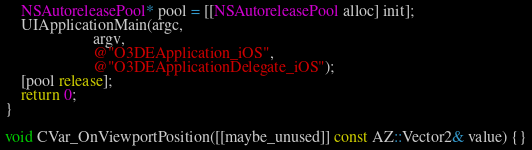<code> <loc_0><loc_0><loc_500><loc_500><_ObjectiveC_>    NSAutoreleasePool* pool = [[NSAutoreleasePool alloc] init];
    UIApplicationMain(argc,
                      argv,
                      @"O3DEApplication_iOS",
                      @"O3DEApplicationDelegate_iOS");
    [pool release];
    return 0;
}

void CVar_OnViewportPosition([[maybe_unused]] const AZ::Vector2& value) {}
</code> 